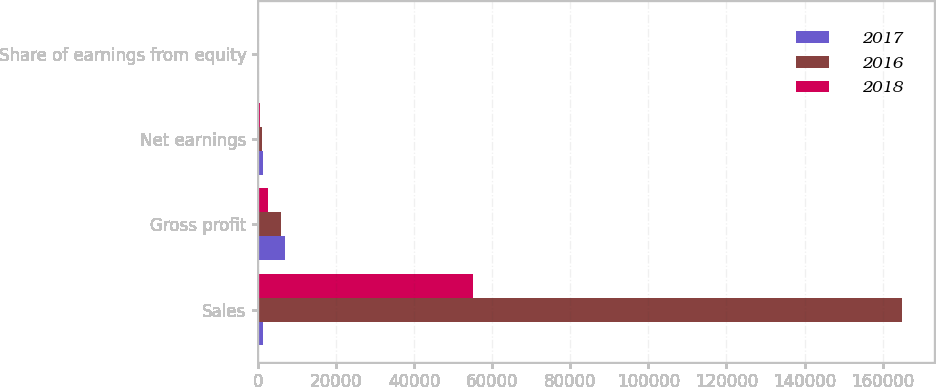Convert chart to OTSL. <chart><loc_0><loc_0><loc_500><loc_500><stacked_bar_chart><ecel><fcel>Sales<fcel>Gross profit<fcel>Net earnings<fcel>Share of earnings from equity<nl><fcel>2017<fcel>1315<fcel>6875<fcel>1315<fcel>245<nl><fcel>2016<fcel>164844<fcel>5958<fcel>1040<fcel>143<nl><fcel>2018<fcel>55153<fcel>2672<fcel>534<fcel>81<nl></chart> 